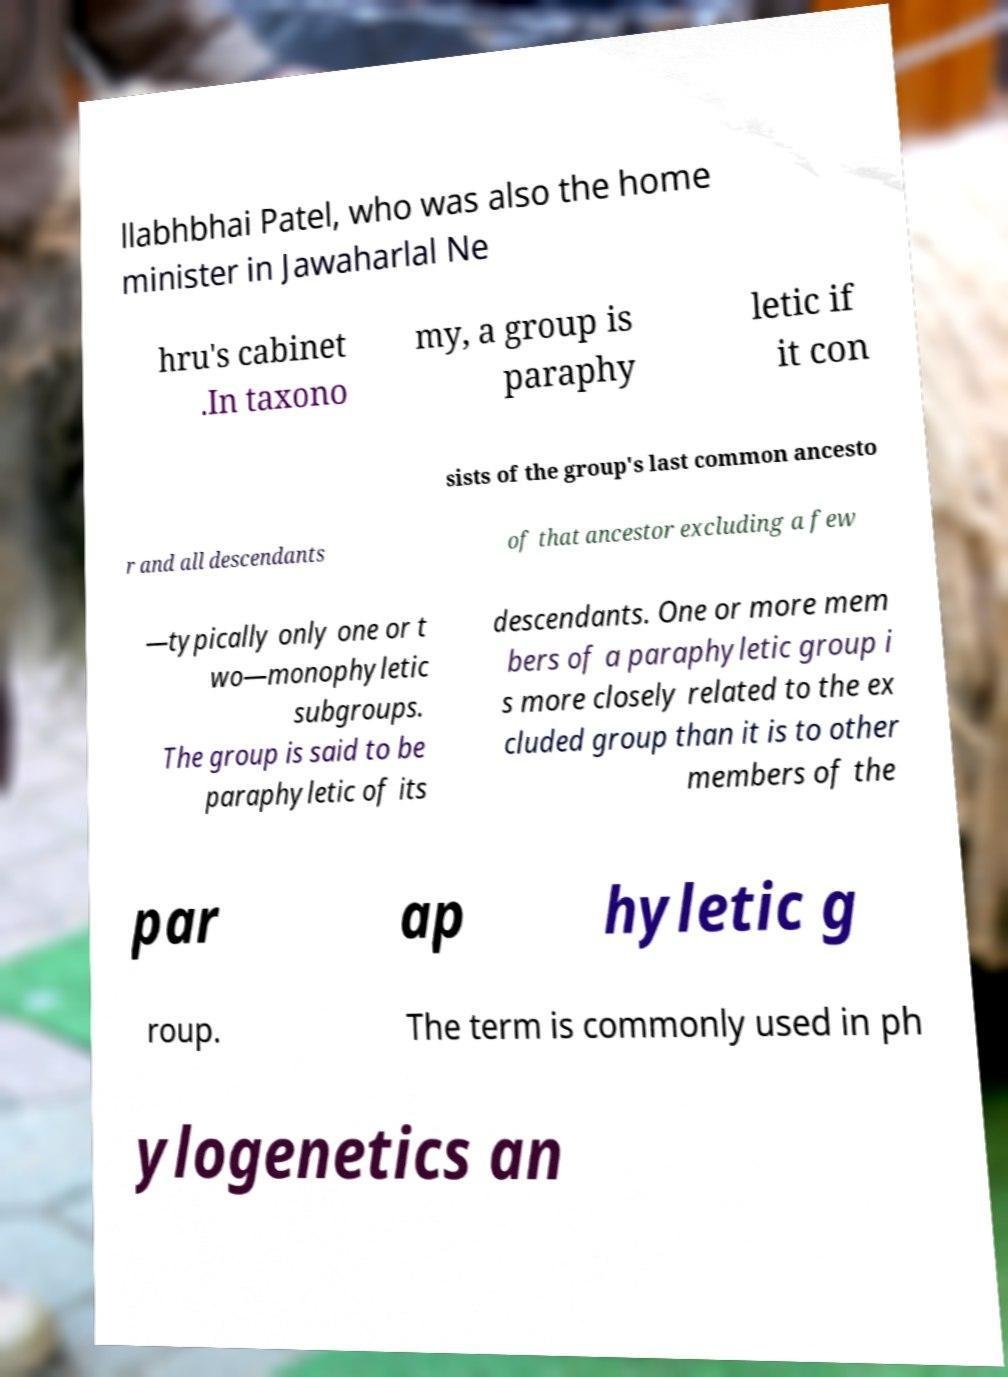Please identify and transcribe the text found in this image. llabhbhai Patel, who was also the home minister in Jawaharlal Ne hru's cabinet .In taxono my, a group is paraphy letic if it con sists of the group's last common ancesto r and all descendants of that ancestor excluding a few —typically only one or t wo—monophyletic subgroups. The group is said to be paraphyletic of its descendants. One or more mem bers of a paraphyletic group i s more closely related to the ex cluded group than it is to other members of the par ap hyletic g roup. The term is commonly used in ph ylogenetics an 